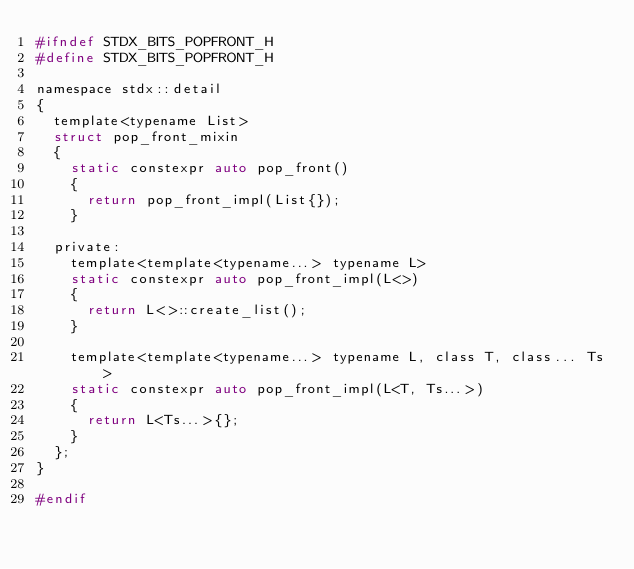Convert code to text. <code><loc_0><loc_0><loc_500><loc_500><_C_>#ifndef STDX_BITS_POPFRONT_H
#define STDX_BITS_POPFRONT_H

namespace stdx::detail
{
  template<typename List>
  struct pop_front_mixin
  {
    static constexpr auto pop_front()
    {
      return pop_front_impl(List{});
    }

  private:
    template<template<typename...> typename L>
    static constexpr auto pop_front_impl(L<>)
    {
      return L<>::create_list();
    }

    template<template<typename...> typename L, class T, class... Ts>
    static constexpr auto pop_front_impl(L<T, Ts...>)
    {
      return L<Ts...>{};
    }
  };
}

#endif
</code> 